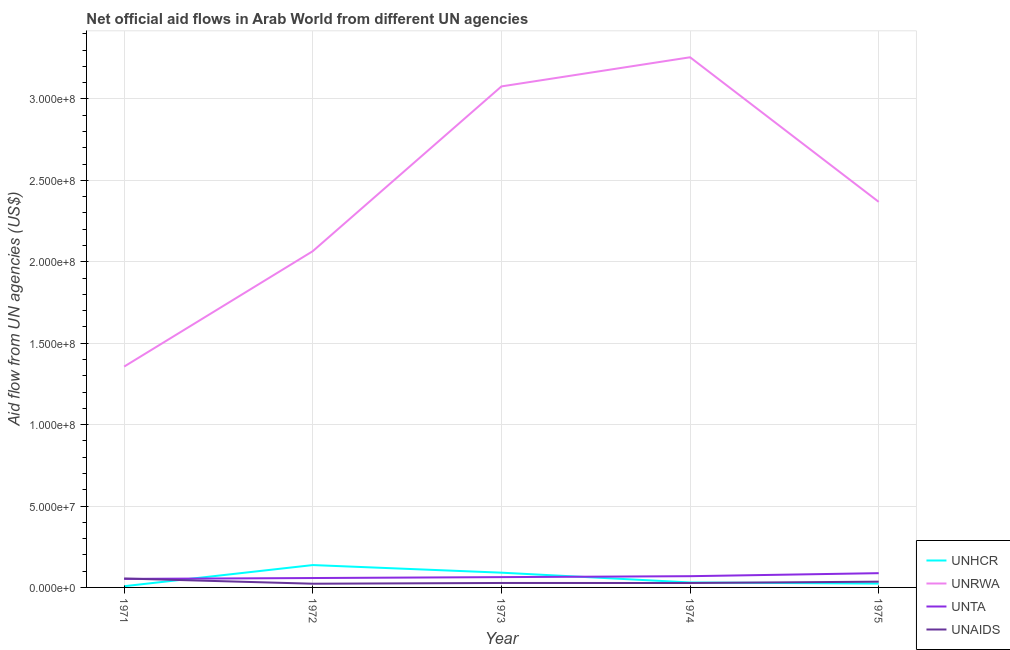How many different coloured lines are there?
Ensure brevity in your answer.  4. Does the line corresponding to amount of aid given by unhcr intersect with the line corresponding to amount of aid given by unta?
Make the answer very short. Yes. What is the amount of aid given by unrwa in 1974?
Give a very brief answer. 3.26e+08. Across all years, what is the maximum amount of aid given by unhcr?
Offer a very short reply. 1.37e+07. Across all years, what is the minimum amount of aid given by unta?
Your response must be concise. 5.23e+06. What is the total amount of aid given by unrwa in the graph?
Your answer should be compact. 1.21e+09. What is the difference between the amount of aid given by unta in 1972 and that in 1975?
Provide a succinct answer. -2.98e+06. What is the difference between the amount of aid given by unta in 1975 and the amount of aid given by unrwa in 1971?
Offer a terse response. -1.27e+08. What is the average amount of aid given by unrwa per year?
Offer a terse response. 2.42e+08. In the year 1974, what is the difference between the amount of aid given by unrwa and amount of aid given by unta?
Provide a short and direct response. 3.19e+08. What is the ratio of the amount of aid given by unrwa in 1971 to that in 1972?
Your response must be concise. 0.66. Is the amount of aid given by unhcr in 1971 less than that in 1975?
Your response must be concise. Yes. What is the difference between the highest and the second highest amount of aid given by unrwa?
Keep it short and to the point. 1.79e+07. What is the difference between the highest and the lowest amount of aid given by unhcr?
Provide a short and direct response. 1.30e+07. Is the sum of the amount of aid given by unta in 1971 and 1972 greater than the maximum amount of aid given by unhcr across all years?
Provide a succinct answer. No. Is it the case that in every year, the sum of the amount of aid given by unrwa and amount of aid given by unta is greater than the sum of amount of aid given by unhcr and amount of aid given by unaids?
Ensure brevity in your answer.  Yes. Does the amount of aid given by unta monotonically increase over the years?
Your answer should be compact. Yes. Is the amount of aid given by unta strictly greater than the amount of aid given by unrwa over the years?
Your answer should be very brief. No. How many years are there in the graph?
Offer a very short reply. 5. What is the difference between two consecutive major ticks on the Y-axis?
Offer a terse response. 5.00e+07. Are the values on the major ticks of Y-axis written in scientific E-notation?
Offer a very short reply. Yes. Where does the legend appear in the graph?
Offer a terse response. Bottom right. What is the title of the graph?
Your answer should be compact. Net official aid flows in Arab World from different UN agencies. What is the label or title of the Y-axis?
Your answer should be compact. Aid flow from UN agencies (US$). What is the Aid flow from UN agencies (US$) of UNHCR in 1971?
Offer a terse response. 7.50e+05. What is the Aid flow from UN agencies (US$) in UNRWA in 1971?
Ensure brevity in your answer.  1.36e+08. What is the Aid flow from UN agencies (US$) in UNTA in 1971?
Offer a very short reply. 5.23e+06. What is the Aid flow from UN agencies (US$) of UNAIDS in 1971?
Your answer should be very brief. 5.49e+06. What is the Aid flow from UN agencies (US$) in UNHCR in 1972?
Your answer should be very brief. 1.37e+07. What is the Aid flow from UN agencies (US$) in UNRWA in 1972?
Your response must be concise. 2.07e+08. What is the Aid flow from UN agencies (US$) in UNTA in 1972?
Provide a succinct answer. 5.77e+06. What is the Aid flow from UN agencies (US$) of UNAIDS in 1972?
Your response must be concise. 2.28e+06. What is the Aid flow from UN agencies (US$) in UNHCR in 1973?
Offer a very short reply. 9.06e+06. What is the Aid flow from UN agencies (US$) in UNRWA in 1973?
Give a very brief answer. 3.08e+08. What is the Aid flow from UN agencies (US$) in UNTA in 1973?
Provide a short and direct response. 6.33e+06. What is the Aid flow from UN agencies (US$) of UNAIDS in 1973?
Keep it short and to the point. 2.74e+06. What is the Aid flow from UN agencies (US$) of UNHCR in 1974?
Offer a terse response. 3.05e+06. What is the Aid flow from UN agencies (US$) in UNRWA in 1974?
Make the answer very short. 3.26e+08. What is the Aid flow from UN agencies (US$) in UNTA in 1974?
Provide a succinct answer. 6.90e+06. What is the Aid flow from UN agencies (US$) of UNAIDS in 1974?
Keep it short and to the point. 2.72e+06. What is the Aid flow from UN agencies (US$) of UNHCR in 1975?
Make the answer very short. 2.35e+06. What is the Aid flow from UN agencies (US$) of UNRWA in 1975?
Ensure brevity in your answer.  2.37e+08. What is the Aid flow from UN agencies (US$) of UNTA in 1975?
Give a very brief answer. 8.75e+06. What is the Aid flow from UN agencies (US$) in UNAIDS in 1975?
Offer a very short reply. 3.53e+06. Across all years, what is the maximum Aid flow from UN agencies (US$) of UNHCR?
Provide a succinct answer. 1.37e+07. Across all years, what is the maximum Aid flow from UN agencies (US$) of UNRWA?
Provide a short and direct response. 3.26e+08. Across all years, what is the maximum Aid flow from UN agencies (US$) of UNTA?
Offer a terse response. 8.75e+06. Across all years, what is the maximum Aid flow from UN agencies (US$) in UNAIDS?
Offer a very short reply. 5.49e+06. Across all years, what is the minimum Aid flow from UN agencies (US$) of UNHCR?
Your answer should be compact. 7.50e+05. Across all years, what is the minimum Aid flow from UN agencies (US$) of UNRWA?
Make the answer very short. 1.36e+08. Across all years, what is the minimum Aid flow from UN agencies (US$) in UNTA?
Provide a succinct answer. 5.23e+06. Across all years, what is the minimum Aid flow from UN agencies (US$) of UNAIDS?
Offer a terse response. 2.28e+06. What is the total Aid flow from UN agencies (US$) of UNHCR in the graph?
Offer a terse response. 2.89e+07. What is the total Aid flow from UN agencies (US$) of UNRWA in the graph?
Your response must be concise. 1.21e+09. What is the total Aid flow from UN agencies (US$) of UNTA in the graph?
Offer a very short reply. 3.30e+07. What is the total Aid flow from UN agencies (US$) in UNAIDS in the graph?
Your response must be concise. 1.68e+07. What is the difference between the Aid flow from UN agencies (US$) of UNHCR in 1971 and that in 1972?
Make the answer very short. -1.30e+07. What is the difference between the Aid flow from UN agencies (US$) of UNRWA in 1971 and that in 1972?
Your answer should be very brief. -7.09e+07. What is the difference between the Aid flow from UN agencies (US$) of UNTA in 1971 and that in 1972?
Provide a succinct answer. -5.40e+05. What is the difference between the Aid flow from UN agencies (US$) in UNAIDS in 1971 and that in 1972?
Ensure brevity in your answer.  3.21e+06. What is the difference between the Aid flow from UN agencies (US$) in UNHCR in 1971 and that in 1973?
Your answer should be compact. -8.31e+06. What is the difference between the Aid flow from UN agencies (US$) in UNRWA in 1971 and that in 1973?
Offer a terse response. -1.72e+08. What is the difference between the Aid flow from UN agencies (US$) in UNTA in 1971 and that in 1973?
Your answer should be very brief. -1.10e+06. What is the difference between the Aid flow from UN agencies (US$) of UNAIDS in 1971 and that in 1973?
Ensure brevity in your answer.  2.75e+06. What is the difference between the Aid flow from UN agencies (US$) of UNHCR in 1971 and that in 1974?
Your answer should be compact. -2.30e+06. What is the difference between the Aid flow from UN agencies (US$) in UNRWA in 1971 and that in 1974?
Offer a very short reply. -1.90e+08. What is the difference between the Aid flow from UN agencies (US$) in UNTA in 1971 and that in 1974?
Ensure brevity in your answer.  -1.67e+06. What is the difference between the Aid flow from UN agencies (US$) of UNAIDS in 1971 and that in 1974?
Ensure brevity in your answer.  2.77e+06. What is the difference between the Aid flow from UN agencies (US$) of UNHCR in 1971 and that in 1975?
Offer a terse response. -1.60e+06. What is the difference between the Aid flow from UN agencies (US$) in UNRWA in 1971 and that in 1975?
Offer a very short reply. -1.01e+08. What is the difference between the Aid flow from UN agencies (US$) of UNTA in 1971 and that in 1975?
Provide a succinct answer. -3.52e+06. What is the difference between the Aid flow from UN agencies (US$) of UNAIDS in 1971 and that in 1975?
Give a very brief answer. 1.96e+06. What is the difference between the Aid flow from UN agencies (US$) of UNHCR in 1972 and that in 1973?
Your answer should be compact. 4.67e+06. What is the difference between the Aid flow from UN agencies (US$) of UNRWA in 1972 and that in 1973?
Ensure brevity in your answer.  -1.01e+08. What is the difference between the Aid flow from UN agencies (US$) in UNTA in 1972 and that in 1973?
Offer a terse response. -5.60e+05. What is the difference between the Aid flow from UN agencies (US$) in UNAIDS in 1972 and that in 1973?
Ensure brevity in your answer.  -4.60e+05. What is the difference between the Aid flow from UN agencies (US$) of UNHCR in 1972 and that in 1974?
Make the answer very short. 1.07e+07. What is the difference between the Aid flow from UN agencies (US$) in UNRWA in 1972 and that in 1974?
Provide a succinct answer. -1.19e+08. What is the difference between the Aid flow from UN agencies (US$) in UNTA in 1972 and that in 1974?
Provide a succinct answer. -1.13e+06. What is the difference between the Aid flow from UN agencies (US$) of UNAIDS in 1972 and that in 1974?
Your response must be concise. -4.40e+05. What is the difference between the Aid flow from UN agencies (US$) of UNHCR in 1972 and that in 1975?
Your response must be concise. 1.14e+07. What is the difference between the Aid flow from UN agencies (US$) of UNRWA in 1972 and that in 1975?
Give a very brief answer. -3.03e+07. What is the difference between the Aid flow from UN agencies (US$) in UNTA in 1972 and that in 1975?
Provide a short and direct response. -2.98e+06. What is the difference between the Aid flow from UN agencies (US$) in UNAIDS in 1972 and that in 1975?
Your answer should be compact. -1.25e+06. What is the difference between the Aid flow from UN agencies (US$) of UNHCR in 1973 and that in 1974?
Ensure brevity in your answer.  6.01e+06. What is the difference between the Aid flow from UN agencies (US$) in UNRWA in 1973 and that in 1974?
Offer a very short reply. -1.79e+07. What is the difference between the Aid flow from UN agencies (US$) in UNTA in 1973 and that in 1974?
Keep it short and to the point. -5.70e+05. What is the difference between the Aid flow from UN agencies (US$) of UNHCR in 1973 and that in 1975?
Provide a short and direct response. 6.71e+06. What is the difference between the Aid flow from UN agencies (US$) of UNRWA in 1973 and that in 1975?
Ensure brevity in your answer.  7.09e+07. What is the difference between the Aid flow from UN agencies (US$) in UNTA in 1973 and that in 1975?
Ensure brevity in your answer.  -2.42e+06. What is the difference between the Aid flow from UN agencies (US$) in UNAIDS in 1973 and that in 1975?
Ensure brevity in your answer.  -7.90e+05. What is the difference between the Aid flow from UN agencies (US$) of UNRWA in 1974 and that in 1975?
Provide a short and direct response. 8.88e+07. What is the difference between the Aid flow from UN agencies (US$) of UNTA in 1974 and that in 1975?
Make the answer very short. -1.85e+06. What is the difference between the Aid flow from UN agencies (US$) in UNAIDS in 1974 and that in 1975?
Your answer should be compact. -8.10e+05. What is the difference between the Aid flow from UN agencies (US$) in UNHCR in 1971 and the Aid flow from UN agencies (US$) in UNRWA in 1972?
Your response must be concise. -2.06e+08. What is the difference between the Aid flow from UN agencies (US$) in UNHCR in 1971 and the Aid flow from UN agencies (US$) in UNTA in 1972?
Ensure brevity in your answer.  -5.02e+06. What is the difference between the Aid flow from UN agencies (US$) of UNHCR in 1971 and the Aid flow from UN agencies (US$) of UNAIDS in 1972?
Your response must be concise. -1.53e+06. What is the difference between the Aid flow from UN agencies (US$) of UNRWA in 1971 and the Aid flow from UN agencies (US$) of UNTA in 1972?
Offer a very short reply. 1.30e+08. What is the difference between the Aid flow from UN agencies (US$) in UNRWA in 1971 and the Aid flow from UN agencies (US$) in UNAIDS in 1972?
Provide a short and direct response. 1.33e+08. What is the difference between the Aid flow from UN agencies (US$) of UNTA in 1971 and the Aid flow from UN agencies (US$) of UNAIDS in 1972?
Offer a very short reply. 2.95e+06. What is the difference between the Aid flow from UN agencies (US$) of UNHCR in 1971 and the Aid flow from UN agencies (US$) of UNRWA in 1973?
Ensure brevity in your answer.  -3.07e+08. What is the difference between the Aid flow from UN agencies (US$) in UNHCR in 1971 and the Aid flow from UN agencies (US$) in UNTA in 1973?
Your answer should be compact. -5.58e+06. What is the difference between the Aid flow from UN agencies (US$) of UNHCR in 1971 and the Aid flow from UN agencies (US$) of UNAIDS in 1973?
Provide a succinct answer. -1.99e+06. What is the difference between the Aid flow from UN agencies (US$) of UNRWA in 1971 and the Aid flow from UN agencies (US$) of UNTA in 1973?
Ensure brevity in your answer.  1.29e+08. What is the difference between the Aid flow from UN agencies (US$) of UNRWA in 1971 and the Aid flow from UN agencies (US$) of UNAIDS in 1973?
Provide a succinct answer. 1.33e+08. What is the difference between the Aid flow from UN agencies (US$) of UNTA in 1971 and the Aid flow from UN agencies (US$) of UNAIDS in 1973?
Your answer should be very brief. 2.49e+06. What is the difference between the Aid flow from UN agencies (US$) of UNHCR in 1971 and the Aid flow from UN agencies (US$) of UNRWA in 1974?
Your answer should be very brief. -3.25e+08. What is the difference between the Aid flow from UN agencies (US$) in UNHCR in 1971 and the Aid flow from UN agencies (US$) in UNTA in 1974?
Provide a succinct answer. -6.15e+06. What is the difference between the Aid flow from UN agencies (US$) of UNHCR in 1971 and the Aid flow from UN agencies (US$) of UNAIDS in 1974?
Your answer should be very brief. -1.97e+06. What is the difference between the Aid flow from UN agencies (US$) in UNRWA in 1971 and the Aid flow from UN agencies (US$) in UNTA in 1974?
Ensure brevity in your answer.  1.29e+08. What is the difference between the Aid flow from UN agencies (US$) of UNRWA in 1971 and the Aid flow from UN agencies (US$) of UNAIDS in 1974?
Ensure brevity in your answer.  1.33e+08. What is the difference between the Aid flow from UN agencies (US$) of UNTA in 1971 and the Aid flow from UN agencies (US$) of UNAIDS in 1974?
Make the answer very short. 2.51e+06. What is the difference between the Aid flow from UN agencies (US$) in UNHCR in 1971 and the Aid flow from UN agencies (US$) in UNRWA in 1975?
Make the answer very short. -2.36e+08. What is the difference between the Aid flow from UN agencies (US$) in UNHCR in 1971 and the Aid flow from UN agencies (US$) in UNTA in 1975?
Your answer should be compact. -8.00e+06. What is the difference between the Aid flow from UN agencies (US$) of UNHCR in 1971 and the Aid flow from UN agencies (US$) of UNAIDS in 1975?
Offer a terse response. -2.78e+06. What is the difference between the Aid flow from UN agencies (US$) in UNRWA in 1971 and the Aid flow from UN agencies (US$) in UNTA in 1975?
Offer a terse response. 1.27e+08. What is the difference between the Aid flow from UN agencies (US$) of UNRWA in 1971 and the Aid flow from UN agencies (US$) of UNAIDS in 1975?
Offer a terse response. 1.32e+08. What is the difference between the Aid flow from UN agencies (US$) of UNTA in 1971 and the Aid flow from UN agencies (US$) of UNAIDS in 1975?
Your answer should be compact. 1.70e+06. What is the difference between the Aid flow from UN agencies (US$) in UNHCR in 1972 and the Aid flow from UN agencies (US$) in UNRWA in 1973?
Your answer should be very brief. -2.94e+08. What is the difference between the Aid flow from UN agencies (US$) of UNHCR in 1972 and the Aid flow from UN agencies (US$) of UNTA in 1973?
Your response must be concise. 7.40e+06. What is the difference between the Aid flow from UN agencies (US$) in UNHCR in 1972 and the Aid flow from UN agencies (US$) in UNAIDS in 1973?
Your response must be concise. 1.10e+07. What is the difference between the Aid flow from UN agencies (US$) in UNRWA in 1972 and the Aid flow from UN agencies (US$) in UNTA in 1973?
Keep it short and to the point. 2.00e+08. What is the difference between the Aid flow from UN agencies (US$) of UNRWA in 1972 and the Aid flow from UN agencies (US$) of UNAIDS in 1973?
Your answer should be very brief. 2.04e+08. What is the difference between the Aid flow from UN agencies (US$) in UNTA in 1972 and the Aid flow from UN agencies (US$) in UNAIDS in 1973?
Offer a very short reply. 3.03e+06. What is the difference between the Aid flow from UN agencies (US$) in UNHCR in 1972 and the Aid flow from UN agencies (US$) in UNRWA in 1974?
Offer a terse response. -3.12e+08. What is the difference between the Aid flow from UN agencies (US$) in UNHCR in 1972 and the Aid flow from UN agencies (US$) in UNTA in 1974?
Your answer should be compact. 6.83e+06. What is the difference between the Aid flow from UN agencies (US$) in UNHCR in 1972 and the Aid flow from UN agencies (US$) in UNAIDS in 1974?
Make the answer very short. 1.10e+07. What is the difference between the Aid flow from UN agencies (US$) in UNRWA in 1972 and the Aid flow from UN agencies (US$) in UNTA in 1974?
Keep it short and to the point. 2.00e+08. What is the difference between the Aid flow from UN agencies (US$) in UNRWA in 1972 and the Aid flow from UN agencies (US$) in UNAIDS in 1974?
Ensure brevity in your answer.  2.04e+08. What is the difference between the Aid flow from UN agencies (US$) in UNTA in 1972 and the Aid flow from UN agencies (US$) in UNAIDS in 1974?
Your response must be concise. 3.05e+06. What is the difference between the Aid flow from UN agencies (US$) in UNHCR in 1972 and the Aid flow from UN agencies (US$) in UNRWA in 1975?
Offer a terse response. -2.23e+08. What is the difference between the Aid flow from UN agencies (US$) in UNHCR in 1972 and the Aid flow from UN agencies (US$) in UNTA in 1975?
Your answer should be compact. 4.98e+06. What is the difference between the Aid flow from UN agencies (US$) in UNHCR in 1972 and the Aid flow from UN agencies (US$) in UNAIDS in 1975?
Offer a very short reply. 1.02e+07. What is the difference between the Aid flow from UN agencies (US$) in UNRWA in 1972 and the Aid flow from UN agencies (US$) in UNTA in 1975?
Your answer should be very brief. 1.98e+08. What is the difference between the Aid flow from UN agencies (US$) in UNRWA in 1972 and the Aid flow from UN agencies (US$) in UNAIDS in 1975?
Ensure brevity in your answer.  2.03e+08. What is the difference between the Aid flow from UN agencies (US$) of UNTA in 1972 and the Aid flow from UN agencies (US$) of UNAIDS in 1975?
Offer a terse response. 2.24e+06. What is the difference between the Aid flow from UN agencies (US$) in UNHCR in 1973 and the Aid flow from UN agencies (US$) in UNRWA in 1974?
Your answer should be very brief. -3.17e+08. What is the difference between the Aid flow from UN agencies (US$) in UNHCR in 1973 and the Aid flow from UN agencies (US$) in UNTA in 1974?
Provide a succinct answer. 2.16e+06. What is the difference between the Aid flow from UN agencies (US$) in UNHCR in 1973 and the Aid flow from UN agencies (US$) in UNAIDS in 1974?
Your answer should be compact. 6.34e+06. What is the difference between the Aid flow from UN agencies (US$) in UNRWA in 1973 and the Aid flow from UN agencies (US$) in UNTA in 1974?
Offer a terse response. 3.01e+08. What is the difference between the Aid flow from UN agencies (US$) in UNRWA in 1973 and the Aid flow from UN agencies (US$) in UNAIDS in 1974?
Your response must be concise. 3.05e+08. What is the difference between the Aid flow from UN agencies (US$) of UNTA in 1973 and the Aid flow from UN agencies (US$) of UNAIDS in 1974?
Keep it short and to the point. 3.61e+06. What is the difference between the Aid flow from UN agencies (US$) of UNHCR in 1973 and the Aid flow from UN agencies (US$) of UNRWA in 1975?
Your response must be concise. -2.28e+08. What is the difference between the Aid flow from UN agencies (US$) in UNHCR in 1973 and the Aid flow from UN agencies (US$) in UNTA in 1975?
Keep it short and to the point. 3.10e+05. What is the difference between the Aid flow from UN agencies (US$) of UNHCR in 1973 and the Aid flow from UN agencies (US$) of UNAIDS in 1975?
Provide a succinct answer. 5.53e+06. What is the difference between the Aid flow from UN agencies (US$) in UNRWA in 1973 and the Aid flow from UN agencies (US$) in UNTA in 1975?
Keep it short and to the point. 2.99e+08. What is the difference between the Aid flow from UN agencies (US$) of UNRWA in 1973 and the Aid flow from UN agencies (US$) of UNAIDS in 1975?
Give a very brief answer. 3.04e+08. What is the difference between the Aid flow from UN agencies (US$) in UNTA in 1973 and the Aid flow from UN agencies (US$) in UNAIDS in 1975?
Offer a very short reply. 2.80e+06. What is the difference between the Aid flow from UN agencies (US$) of UNHCR in 1974 and the Aid flow from UN agencies (US$) of UNRWA in 1975?
Offer a very short reply. -2.34e+08. What is the difference between the Aid flow from UN agencies (US$) in UNHCR in 1974 and the Aid flow from UN agencies (US$) in UNTA in 1975?
Your response must be concise. -5.70e+06. What is the difference between the Aid flow from UN agencies (US$) in UNHCR in 1974 and the Aid flow from UN agencies (US$) in UNAIDS in 1975?
Offer a terse response. -4.80e+05. What is the difference between the Aid flow from UN agencies (US$) in UNRWA in 1974 and the Aid flow from UN agencies (US$) in UNTA in 1975?
Your answer should be very brief. 3.17e+08. What is the difference between the Aid flow from UN agencies (US$) in UNRWA in 1974 and the Aid flow from UN agencies (US$) in UNAIDS in 1975?
Your answer should be very brief. 3.22e+08. What is the difference between the Aid flow from UN agencies (US$) of UNTA in 1974 and the Aid flow from UN agencies (US$) of UNAIDS in 1975?
Ensure brevity in your answer.  3.37e+06. What is the average Aid flow from UN agencies (US$) of UNHCR per year?
Give a very brief answer. 5.79e+06. What is the average Aid flow from UN agencies (US$) in UNRWA per year?
Your answer should be very brief. 2.42e+08. What is the average Aid flow from UN agencies (US$) of UNTA per year?
Ensure brevity in your answer.  6.60e+06. What is the average Aid flow from UN agencies (US$) in UNAIDS per year?
Offer a very short reply. 3.35e+06. In the year 1971, what is the difference between the Aid flow from UN agencies (US$) of UNHCR and Aid flow from UN agencies (US$) of UNRWA?
Keep it short and to the point. -1.35e+08. In the year 1971, what is the difference between the Aid flow from UN agencies (US$) of UNHCR and Aid flow from UN agencies (US$) of UNTA?
Your response must be concise. -4.48e+06. In the year 1971, what is the difference between the Aid flow from UN agencies (US$) in UNHCR and Aid flow from UN agencies (US$) in UNAIDS?
Offer a terse response. -4.74e+06. In the year 1971, what is the difference between the Aid flow from UN agencies (US$) in UNRWA and Aid flow from UN agencies (US$) in UNTA?
Ensure brevity in your answer.  1.30e+08. In the year 1971, what is the difference between the Aid flow from UN agencies (US$) in UNRWA and Aid flow from UN agencies (US$) in UNAIDS?
Your answer should be very brief. 1.30e+08. In the year 1971, what is the difference between the Aid flow from UN agencies (US$) in UNTA and Aid flow from UN agencies (US$) in UNAIDS?
Give a very brief answer. -2.60e+05. In the year 1972, what is the difference between the Aid flow from UN agencies (US$) of UNHCR and Aid flow from UN agencies (US$) of UNRWA?
Offer a very short reply. -1.93e+08. In the year 1972, what is the difference between the Aid flow from UN agencies (US$) in UNHCR and Aid flow from UN agencies (US$) in UNTA?
Keep it short and to the point. 7.96e+06. In the year 1972, what is the difference between the Aid flow from UN agencies (US$) of UNHCR and Aid flow from UN agencies (US$) of UNAIDS?
Offer a terse response. 1.14e+07. In the year 1972, what is the difference between the Aid flow from UN agencies (US$) in UNRWA and Aid flow from UN agencies (US$) in UNTA?
Your answer should be compact. 2.01e+08. In the year 1972, what is the difference between the Aid flow from UN agencies (US$) in UNRWA and Aid flow from UN agencies (US$) in UNAIDS?
Provide a short and direct response. 2.04e+08. In the year 1972, what is the difference between the Aid flow from UN agencies (US$) of UNTA and Aid flow from UN agencies (US$) of UNAIDS?
Offer a terse response. 3.49e+06. In the year 1973, what is the difference between the Aid flow from UN agencies (US$) in UNHCR and Aid flow from UN agencies (US$) in UNRWA?
Provide a short and direct response. -2.99e+08. In the year 1973, what is the difference between the Aid flow from UN agencies (US$) of UNHCR and Aid flow from UN agencies (US$) of UNTA?
Offer a very short reply. 2.73e+06. In the year 1973, what is the difference between the Aid flow from UN agencies (US$) in UNHCR and Aid flow from UN agencies (US$) in UNAIDS?
Keep it short and to the point. 6.32e+06. In the year 1973, what is the difference between the Aid flow from UN agencies (US$) of UNRWA and Aid flow from UN agencies (US$) of UNTA?
Give a very brief answer. 3.01e+08. In the year 1973, what is the difference between the Aid flow from UN agencies (US$) of UNRWA and Aid flow from UN agencies (US$) of UNAIDS?
Provide a short and direct response. 3.05e+08. In the year 1973, what is the difference between the Aid flow from UN agencies (US$) in UNTA and Aid flow from UN agencies (US$) in UNAIDS?
Offer a terse response. 3.59e+06. In the year 1974, what is the difference between the Aid flow from UN agencies (US$) in UNHCR and Aid flow from UN agencies (US$) in UNRWA?
Provide a succinct answer. -3.23e+08. In the year 1974, what is the difference between the Aid flow from UN agencies (US$) in UNHCR and Aid flow from UN agencies (US$) in UNTA?
Offer a very short reply. -3.85e+06. In the year 1974, what is the difference between the Aid flow from UN agencies (US$) of UNRWA and Aid flow from UN agencies (US$) of UNTA?
Ensure brevity in your answer.  3.19e+08. In the year 1974, what is the difference between the Aid flow from UN agencies (US$) in UNRWA and Aid flow from UN agencies (US$) in UNAIDS?
Your answer should be compact. 3.23e+08. In the year 1974, what is the difference between the Aid flow from UN agencies (US$) of UNTA and Aid flow from UN agencies (US$) of UNAIDS?
Provide a succinct answer. 4.18e+06. In the year 1975, what is the difference between the Aid flow from UN agencies (US$) in UNHCR and Aid flow from UN agencies (US$) in UNRWA?
Your answer should be compact. -2.34e+08. In the year 1975, what is the difference between the Aid flow from UN agencies (US$) of UNHCR and Aid flow from UN agencies (US$) of UNTA?
Provide a short and direct response. -6.40e+06. In the year 1975, what is the difference between the Aid flow from UN agencies (US$) in UNHCR and Aid flow from UN agencies (US$) in UNAIDS?
Offer a terse response. -1.18e+06. In the year 1975, what is the difference between the Aid flow from UN agencies (US$) in UNRWA and Aid flow from UN agencies (US$) in UNTA?
Give a very brief answer. 2.28e+08. In the year 1975, what is the difference between the Aid flow from UN agencies (US$) of UNRWA and Aid flow from UN agencies (US$) of UNAIDS?
Make the answer very short. 2.33e+08. In the year 1975, what is the difference between the Aid flow from UN agencies (US$) in UNTA and Aid flow from UN agencies (US$) in UNAIDS?
Offer a terse response. 5.22e+06. What is the ratio of the Aid flow from UN agencies (US$) in UNHCR in 1971 to that in 1972?
Give a very brief answer. 0.05. What is the ratio of the Aid flow from UN agencies (US$) in UNRWA in 1971 to that in 1972?
Offer a very short reply. 0.66. What is the ratio of the Aid flow from UN agencies (US$) of UNTA in 1971 to that in 1972?
Your answer should be compact. 0.91. What is the ratio of the Aid flow from UN agencies (US$) of UNAIDS in 1971 to that in 1972?
Offer a very short reply. 2.41. What is the ratio of the Aid flow from UN agencies (US$) of UNHCR in 1971 to that in 1973?
Keep it short and to the point. 0.08. What is the ratio of the Aid flow from UN agencies (US$) in UNRWA in 1971 to that in 1973?
Provide a short and direct response. 0.44. What is the ratio of the Aid flow from UN agencies (US$) in UNTA in 1971 to that in 1973?
Your response must be concise. 0.83. What is the ratio of the Aid flow from UN agencies (US$) of UNAIDS in 1971 to that in 1973?
Make the answer very short. 2. What is the ratio of the Aid flow from UN agencies (US$) in UNHCR in 1971 to that in 1974?
Keep it short and to the point. 0.25. What is the ratio of the Aid flow from UN agencies (US$) of UNRWA in 1971 to that in 1974?
Your response must be concise. 0.42. What is the ratio of the Aid flow from UN agencies (US$) of UNTA in 1971 to that in 1974?
Provide a short and direct response. 0.76. What is the ratio of the Aid flow from UN agencies (US$) of UNAIDS in 1971 to that in 1974?
Your answer should be very brief. 2.02. What is the ratio of the Aid flow from UN agencies (US$) of UNHCR in 1971 to that in 1975?
Ensure brevity in your answer.  0.32. What is the ratio of the Aid flow from UN agencies (US$) of UNRWA in 1971 to that in 1975?
Ensure brevity in your answer.  0.57. What is the ratio of the Aid flow from UN agencies (US$) of UNTA in 1971 to that in 1975?
Your response must be concise. 0.6. What is the ratio of the Aid flow from UN agencies (US$) of UNAIDS in 1971 to that in 1975?
Make the answer very short. 1.56. What is the ratio of the Aid flow from UN agencies (US$) in UNHCR in 1972 to that in 1973?
Ensure brevity in your answer.  1.52. What is the ratio of the Aid flow from UN agencies (US$) of UNRWA in 1972 to that in 1973?
Offer a very short reply. 0.67. What is the ratio of the Aid flow from UN agencies (US$) in UNTA in 1972 to that in 1973?
Provide a short and direct response. 0.91. What is the ratio of the Aid flow from UN agencies (US$) in UNAIDS in 1972 to that in 1973?
Your answer should be compact. 0.83. What is the ratio of the Aid flow from UN agencies (US$) of UNHCR in 1972 to that in 1974?
Your answer should be compact. 4.5. What is the ratio of the Aid flow from UN agencies (US$) in UNRWA in 1972 to that in 1974?
Keep it short and to the point. 0.63. What is the ratio of the Aid flow from UN agencies (US$) of UNTA in 1972 to that in 1974?
Give a very brief answer. 0.84. What is the ratio of the Aid flow from UN agencies (US$) of UNAIDS in 1972 to that in 1974?
Give a very brief answer. 0.84. What is the ratio of the Aid flow from UN agencies (US$) in UNHCR in 1972 to that in 1975?
Your response must be concise. 5.84. What is the ratio of the Aid flow from UN agencies (US$) in UNRWA in 1972 to that in 1975?
Provide a succinct answer. 0.87. What is the ratio of the Aid flow from UN agencies (US$) of UNTA in 1972 to that in 1975?
Provide a succinct answer. 0.66. What is the ratio of the Aid flow from UN agencies (US$) in UNAIDS in 1972 to that in 1975?
Offer a very short reply. 0.65. What is the ratio of the Aid flow from UN agencies (US$) in UNHCR in 1973 to that in 1974?
Make the answer very short. 2.97. What is the ratio of the Aid flow from UN agencies (US$) in UNRWA in 1973 to that in 1974?
Keep it short and to the point. 0.95. What is the ratio of the Aid flow from UN agencies (US$) in UNTA in 1973 to that in 1974?
Keep it short and to the point. 0.92. What is the ratio of the Aid flow from UN agencies (US$) of UNAIDS in 1973 to that in 1974?
Offer a terse response. 1.01. What is the ratio of the Aid flow from UN agencies (US$) of UNHCR in 1973 to that in 1975?
Provide a succinct answer. 3.86. What is the ratio of the Aid flow from UN agencies (US$) in UNRWA in 1973 to that in 1975?
Ensure brevity in your answer.  1.3. What is the ratio of the Aid flow from UN agencies (US$) of UNTA in 1973 to that in 1975?
Offer a very short reply. 0.72. What is the ratio of the Aid flow from UN agencies (US$) in UNAIDS in 1973 to that in 1975?
Your response must be concise. 0.78. What is the ratio of the Aid flow from UN agencies (US$) of UNHCR in 1974 to that in 1975?
Your answer should be very brief. 1.3. What is the ratio of the Aid flow from UN agencies (US$) in UNRWA in 1974 to that in 1975?
Make the answer very short. 1.38. What is the ratio of the Aid flow from UN agencies (US$) in UNTA in 1974 to that in 1975?
Your answer should be compact. 0.79. What is the ratio of the Aid flow from UN agencies (US$) in UNAIDS in 1974 to that in 1975?
Provide a succinct answer. 0.77. What is the difference between the highest and the second highest Aid flow from UN agencies (US$) in UNHCR?
Provide a succinct answer. 4.67e+06. What is the difference between the highest and the second highest Aid flow from UN agencies (US$) in UNRWA?
Provide a succinct answer. 1.79e+07. What is the difference between the highest and the second highest Aid flow from UN agencies (US$) of UNTA?
Make the answer very short. 1.85e+06. What is the difference between the highest and the second highest Aid flow from UN agencies (US$) in UNAIDS?
Give a very brief answer. 1.96e+06. What is the difference between the highest and the lowest Aid flow from UN agencies (US$) in UNHCR?
Your response must be concise. 1.30e+07. What is the difference between the highest and the lowest Aid flow from UN agencies (US$) of UNRWA?
Ensure brevity in your answer.  1.90e+08. What is the difference between the highest and the lowest Aid flow from UN agencies (US$) of UNTA?
Your answer should be very brief. 3.52e+06. What is the difference between the highest and the lowest Aid flow from UN agencies (US$) of UNAIDS?
Your answer should be compact. 3.21e+06. 